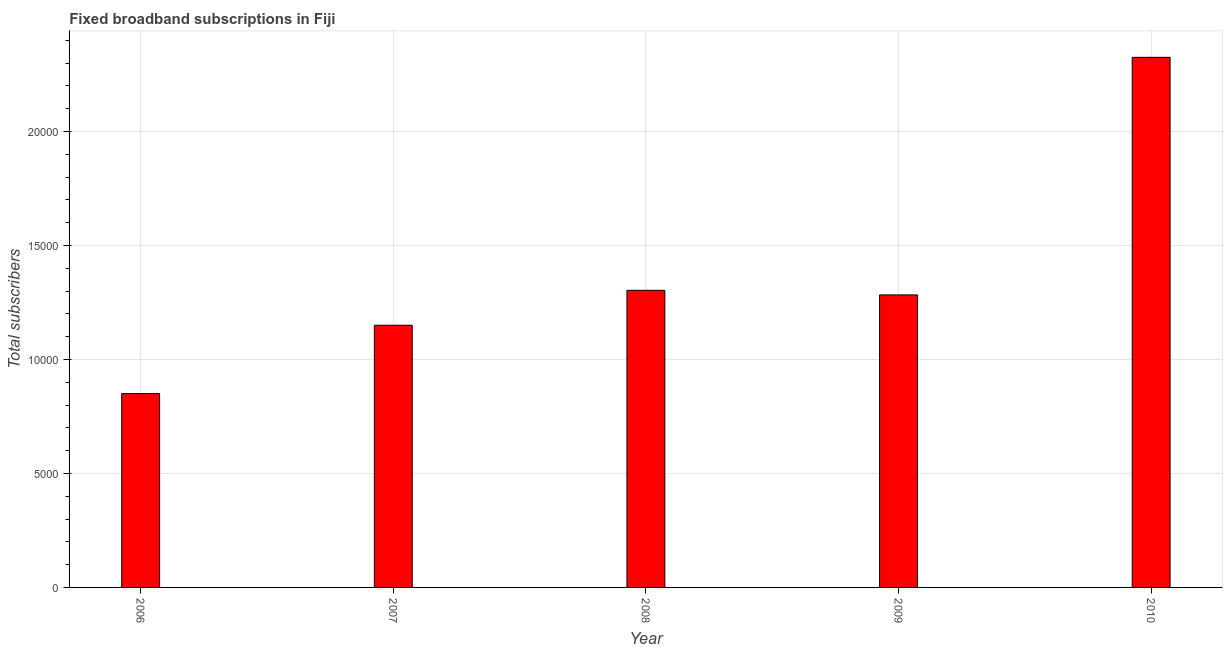Does the graph contain grids?
Your answer should be very brief. Yes. What is the title of the graph?
Make the answer very short. Fixed broadband subscriptions in Fiji. What is the label or title of the Y-axis?
Ensure brevity in your answer.  Total subscribers. What is the total number of fixed broadband subscriptions in 2009?
Your response must be concise. 1.28e+04. Across all years, what is the maximum total number of fixed broadband subscriptions?
Ensure brevity in your answer.  2.32e+04. Across all years, what is the minimum total number of fixed broadband subscriptions?
Ensure brevity in your answer.  8500. In which year was the total number of fixed broadband subscriptions maximum?
Your answer should be very brief. 2010. In which year was the total number of fixed broadband subscriptions minimum?
Your answer should be compact. 2006. What is the sum of the total number of fixed broadband subscriptions?
Your answer should be compact. 6.91e+04. What is the difference between the total number of fixed broadband subscriptions in 2006 and 2009?
Ensure brevity in your answer.  -4330. What is the average total number of fixed broadband subscriptions per year?
Your answer should be compact. 1.38e+04. What is the median total number of fixed broadband subscriptions?
Make the answer very short. 1.28e+04. In how many years, is the total number of fixed broadband subscriptions greater than 6000 ?
Provide a short and direct response. 5. What is the ratio of the total number of fixed broadband subscriptions in 2006 to that in 2010?
Provide a succinct answer. 0.37. What is the difference between the highest and the second highest total number of fixed broadband subscriptions?
Your response must be concise. 1.02e+04. Is the sum of the total number of fixed broadband subscriptions in 2007 and 2008 greater than the maximum total number of fixed broadband subscriptions across all years?
Make the answer very short. Yes. What is the difference between the highest and the lowest total number of fixed broadband subscriptions?
Give a very brief answer. 1.48e+04. In how many years, is the total number of fixed broadband subscriptions greater than the average total number of fixed broadband subscriptions taken over all years?
Your response must be concise. 1. How many bars are there?
Keep it short and to the point. 5. Are all the bars in the graph horizontal?
Make the answer very short. No. How many years are there in the graph?
Your response must be concise. 5. Are the values on the major ticks of Y-axis written in scientific E-notation?
Your answer should be very brief. No. What is the Total subscribers of 2006?
Your answer should be very brief. 8500. What is the Total subscribers of 2007?
Offer a very short reply. 1.15e+04. What is the Total subscribers of 2008?
Your answer should be compact. 1.30e+04. What is the Total subscribers in 2009?
Your response must be concise. 1.28e+04. What is the Total subscribers of 2010?
Give a very brief answer. 2.32e+04. What is the difference between the Total subscribers in 2006 and 2007?
Offer a terse response. -3000. What is the difference between the Total subscribers in 2006 and 2008?
Offer a very short reply. -4531. What is the difference between the Total subscribers in 2006 and 2009?
Provide a short and direct response. -4330. What is the difference between the Total subscribers in 2006 and 2010?
Make the answer very short. -1.48e+04. What is the difference between the Total subscribers in 2007 and 2008?
Ensure brevity in your answer.  -1531. What is the difference between the Total subscribers in 2007 and 2009?
Offer a terse response. -1330. What is the difference between the Total subscribers in 2007 and 2010?
Offer a very short reply. -1.18e+04. What is the difference between the Total subscribers in 2008 and 2009?
Provide a short and direct response. 201. What is the difference between the Total subscribers in 2008 and 2010?
Offer a terse response. -1.02e+04. What is the difference between the Total subscribers in 2009 and 2010?
Offer a very short reply. -1.04e+04. What is the ratio of the Total subscribers in 2006 to that in 2007?
Provide a short and direct response. 0.74. What is the ratio of the Total subscribers in 2006 to that in 2008?
Offer a very short reply. 0.65. What is the ratio of the Total subscribers in 2006 to that in 2009?
Your answer should be compact. 0.66. What is the ratio of the Total subscribers in 2006 to that in 2010?
Your answer should be compact. 0.37. What is the ratio of the Total subscribers in 2007 to that in 2008?
Your answer should be very brief. 0.88. What is the ratio of the Total subscribers in 2007 to that in 2009?
Offer a very short reply. 0.9. What is the ratio of the Total subscribers in 2007 to that in 2010?
Your answer should be compact. 0.49. What is the ratio of the Total subscribers in 2008 to that in 2009?
Your answer should be compact. 1.02. What is the ratio of the Total subscribers in 2008 to that in 2010?
Provide a short and direct response. 0.56. What is the ratio of the Total subscribers in 2009 to that in 2010?
Offer a very short reply. 0.55. 